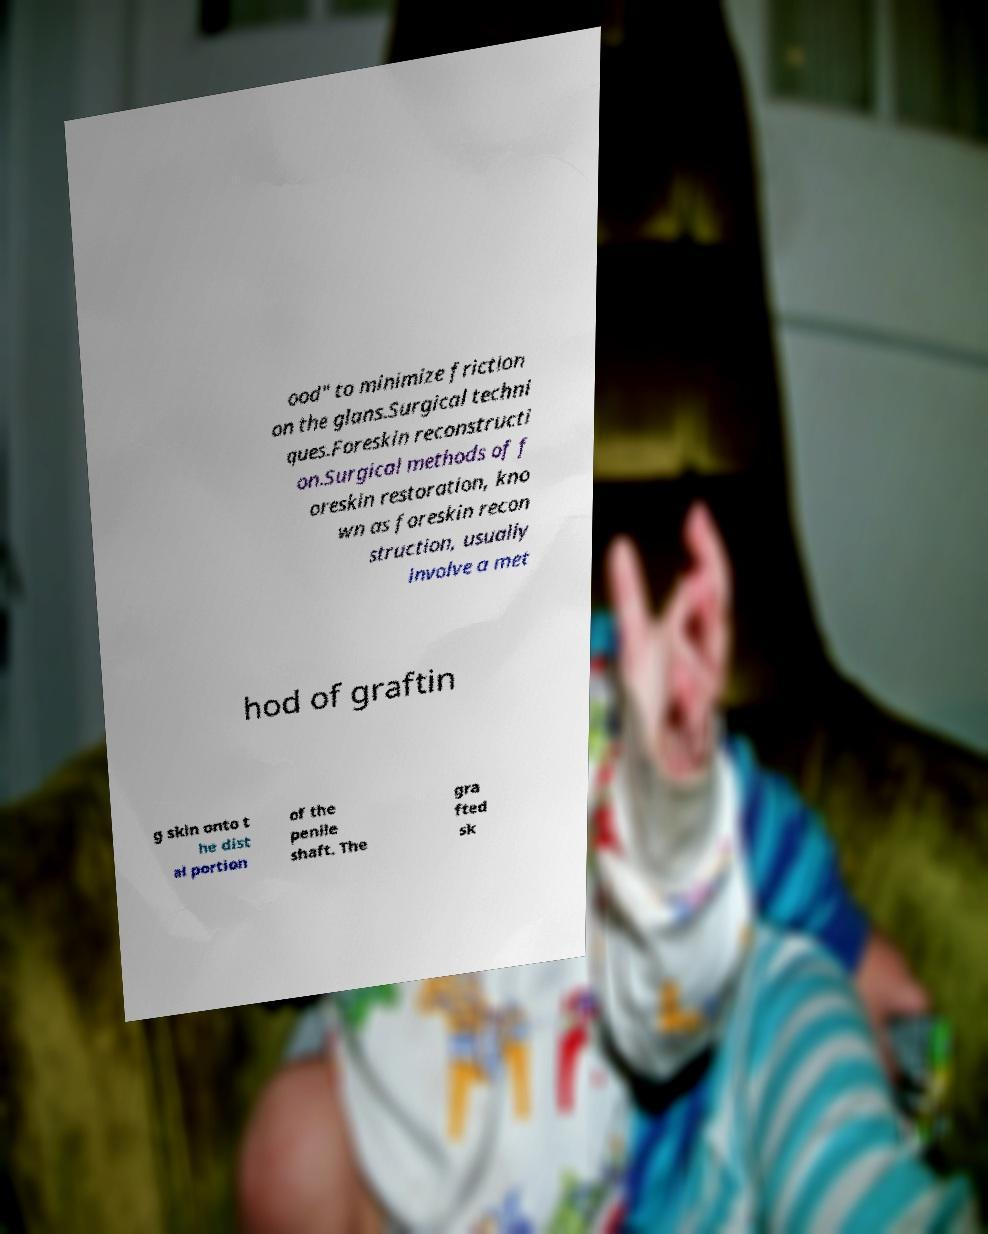Could you assist in decoding the text presented in this image and type it out clearly? ood" to minimize friction on the glans.Surgical techni ques.Foreskin reconstructi on.Surgical methods of f oreskin restoration, kno wn as foreskin recon struction, usually involve a met hod of graftin g skin onto t he dist al portion of the penile shaft. The gra fted sk 